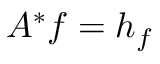<formula> <loc_0><loc_0><loc_500><loc_500>A ^ { * } f = h _ { f }</formula> 